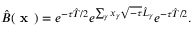<formula> <loc_0><loc_0><loc_500><loc_500>\hat { B } ( x ) = e ^ { - \tau \hat { T } / 2 } e ^ { \sum _ { \gamma } x _ { \gamma } \sqrt { - \tau } \hat { L } _ { \gamma } } e ^ { - \tau \hat { T } / 2 } .</formula> 